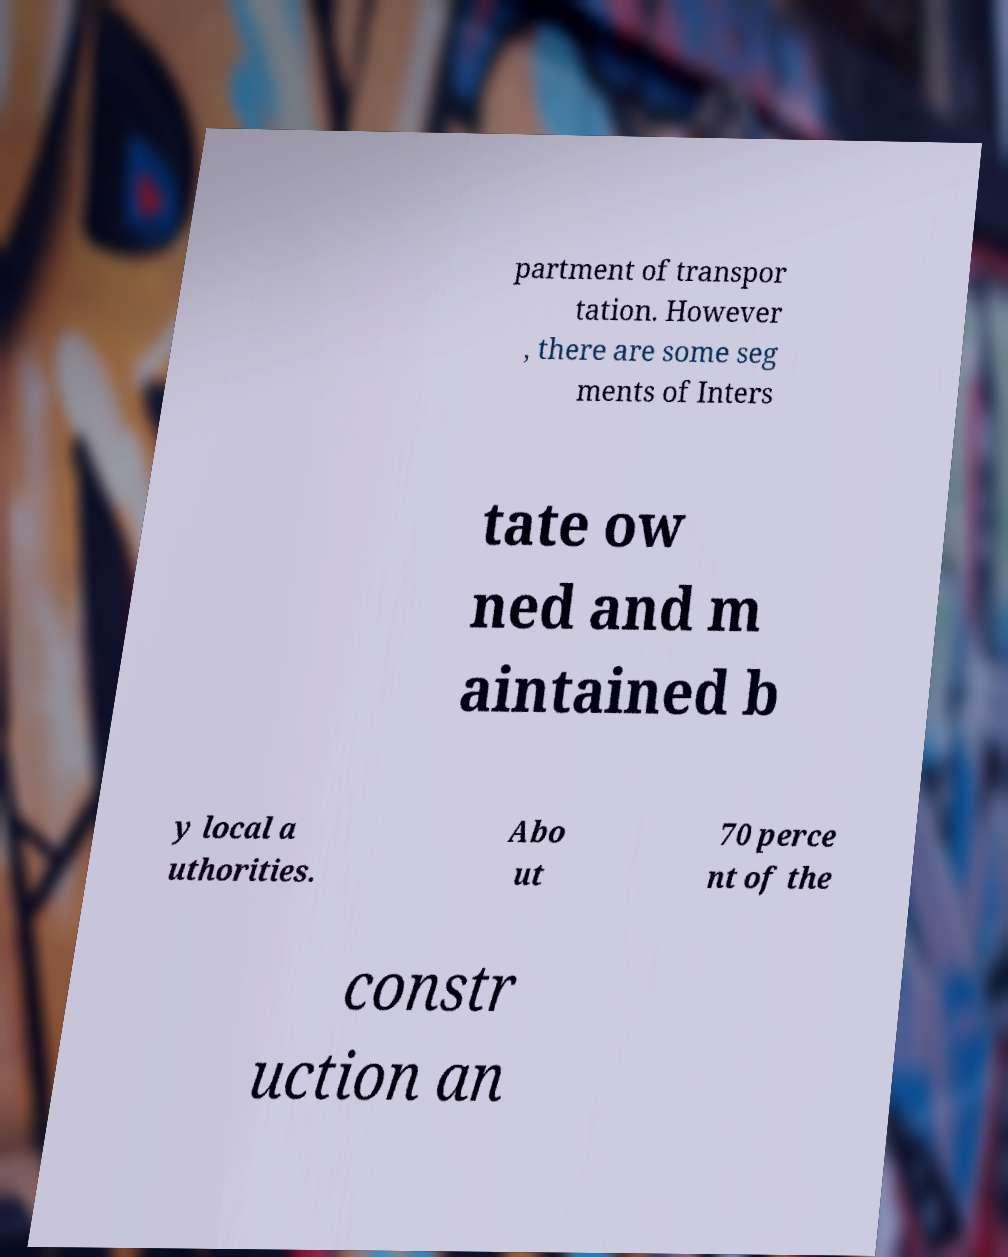There's text embedded in this image that I need extracted. Can you transcribe it verbatim? partment of transpor tation. However , there are some seg ments of Inters tate ow ned and m aintained b y local a uthorities. Abo ut 70 perce nt of the constr uction an 